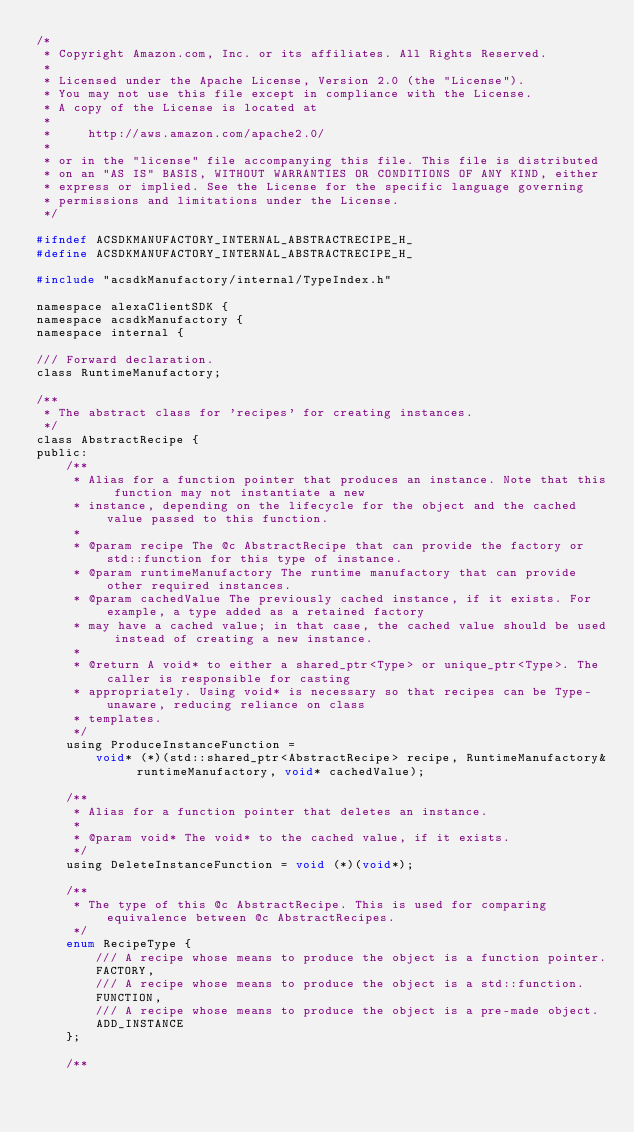Convert code to text. <code><loc_0><loc_0><loc_500><loc_500><_C_>/*
 * Copyright Amazon.com, Inc. or its affiliates. All Rights Reserved.
 *
 * Licensed under the Apache License, Version 2.0 (the "License").
 * You may not use this file except in compliance with the License.
 * A copy of the License is located at
 *
 *     http://aws.amazon.com/apache2.0/
 *
 * or in the "license" file accompanying this file. This file is distributed
 * on an "AS IS" BASIS, WITHOUT WARRANTIES OR CONDITIONS OF ANY KIND, either
 * express or implied. See the License for the specific language governing
 * permissions and limitations under the License.
 */

#ifndef ACSDKMANUFACTORY_INTERNAL_ABSTRACTRECIPE_H_
#define ACSDKMANUFACTORY_INTERNAL_ABSTRACTRECIPE_H_

#include "acsdkManufactory/internal/TypeIndex.h"

namespace alexaClientSDK {
namespace acsdkManufactory {
namespace internal {

/// Forward declaration.
class RuntimeManufactory;

/**
 * The abstract class for 'recipes' for creating instances.
 */
class AbstractRecipe {
public:
    /**
     * Alias for a function pointer that produces an instance. Note that this function may not instantiate a new
     * instance, depending on the lifecycle for the object and the cached value passed to this function.
     *
     * @param recipe The @c AbstractRecipe that can provide the factory or std::function for this type of instance.
     * @param runtimeManufactory The runtime manufactory that can provide other required instances.
     * @param cachedValue The previously cached instance, if it exists. For example, a type added as a retained factory
     * may have a cached value; in that case, the cached value should be used instead of creating a new instance.
     *
     * @return A void* to either a shared_ptr<Type> or unique_ptr<Type>. The caller is responsible for casting
     * appropriately. Using void* is necessary so that recipes can be Type-unaware, reducing reliance on class
     * templates.
     */
    using ProduceInstanceFunction =
        void* (*)(std::shared_ptr<AbstractRecipe> recipe, RuntimeManufactory& runtimeManufactory, void* cachedValue);

    /**
     * Alias for a function pointer that deletes an instance.
     *
     * @param void* The void* to the cached value, if it exists.
     */
    using DeleteInstanceFunction = void (*)(void*);

    /**
     * The type of this @c AbstractRecipe. This is used for comparing equivalence between @c AbstractRecipes.
     */
    enum RecipeType {
        /// A recipe whose means to produce the object is a function pointer.
        FACTORY,
        /// A recipe whose means to produce the object is a std::function.
        FUNCTION,
        /// A recipe whose means to produce the object is a pre-made object.
        ADD_INSTANCE
    };

    /**</code> 